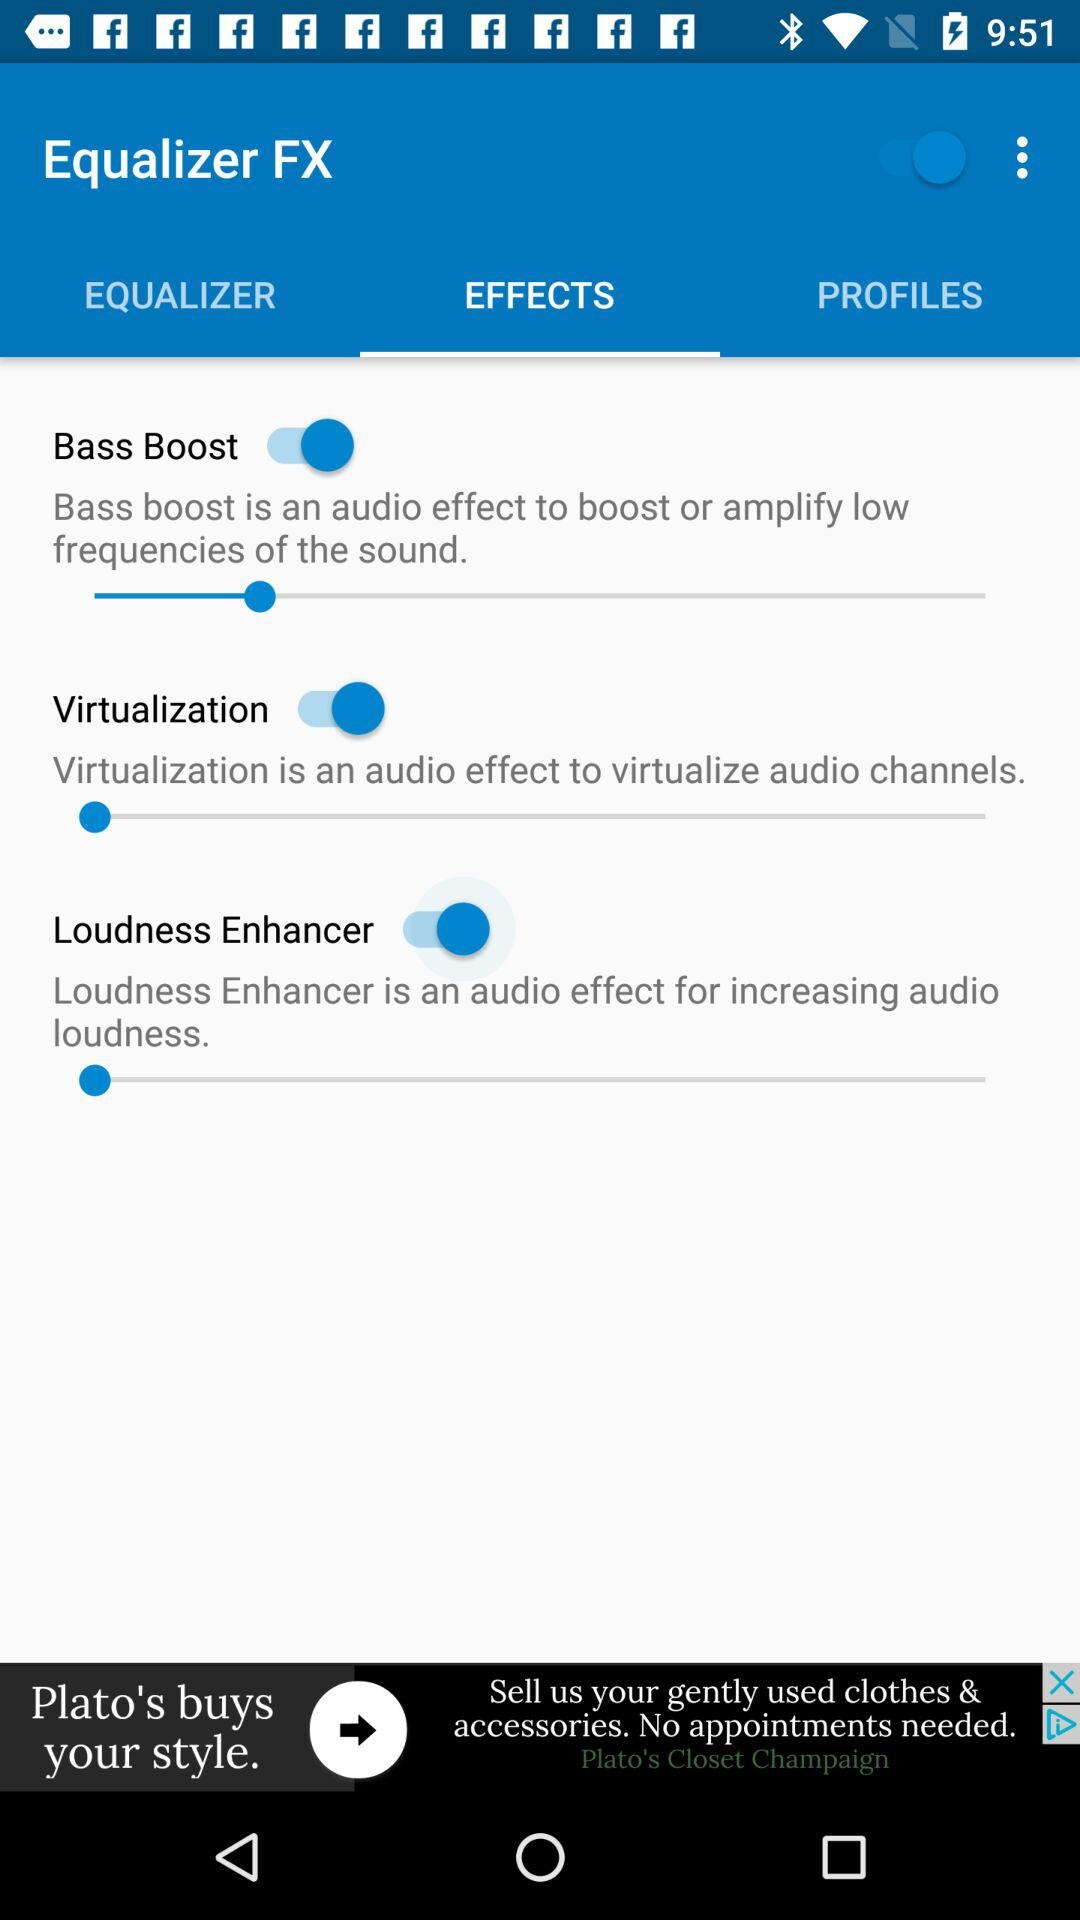Which tab has been selected? The tab that has been selected is "EFFECTS". 